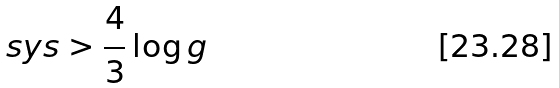<formula> <loc_0><loc_0><loc_500><loc_500>s y s > { \frac { 4 } { 3 } } \log g</formula> 